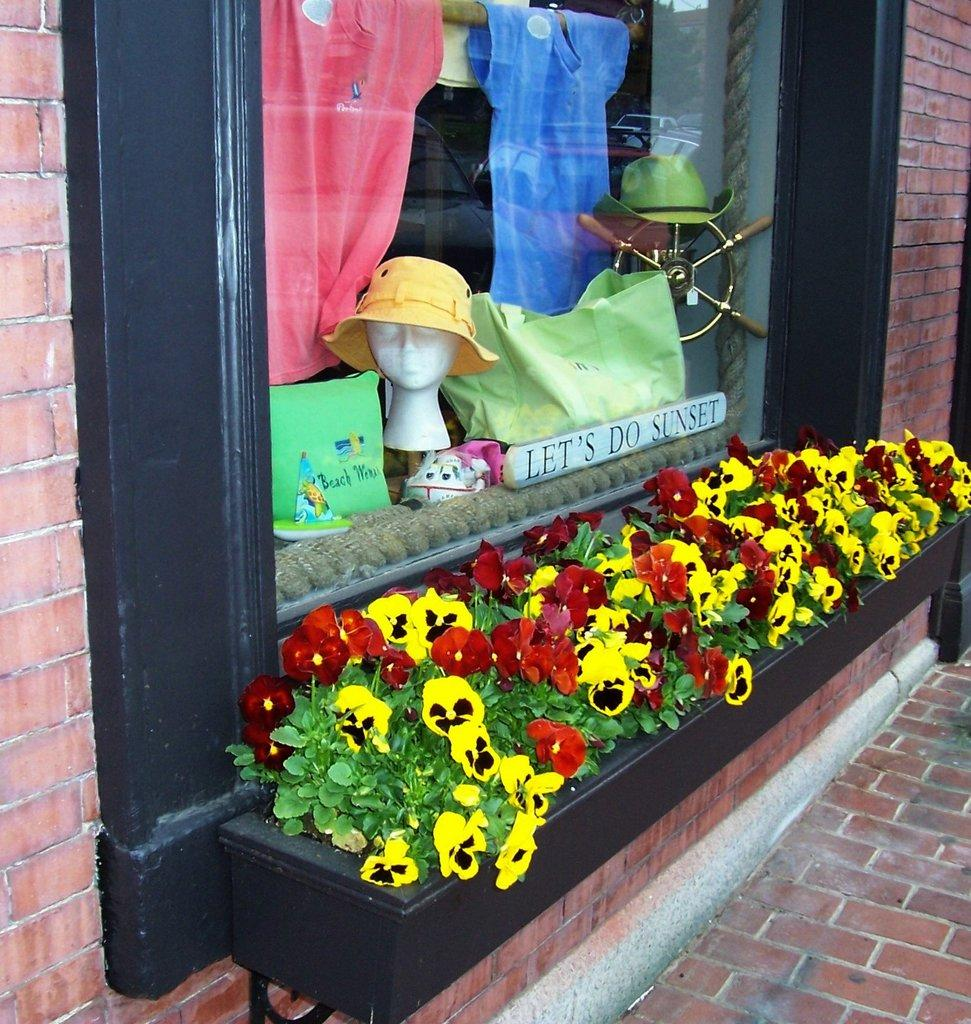What is present on the wall in the image? There is a window in the wall. What can be seen through the window? Clothes and a hat are visible through the window. Are there any plants visible in the image? Yes, there are flowers below the window. What type of brush can be seen in the image? There is no brush present in the image. Can you describe the bat that is hanging from the ceiling in the image? There is no bat present in the image. 